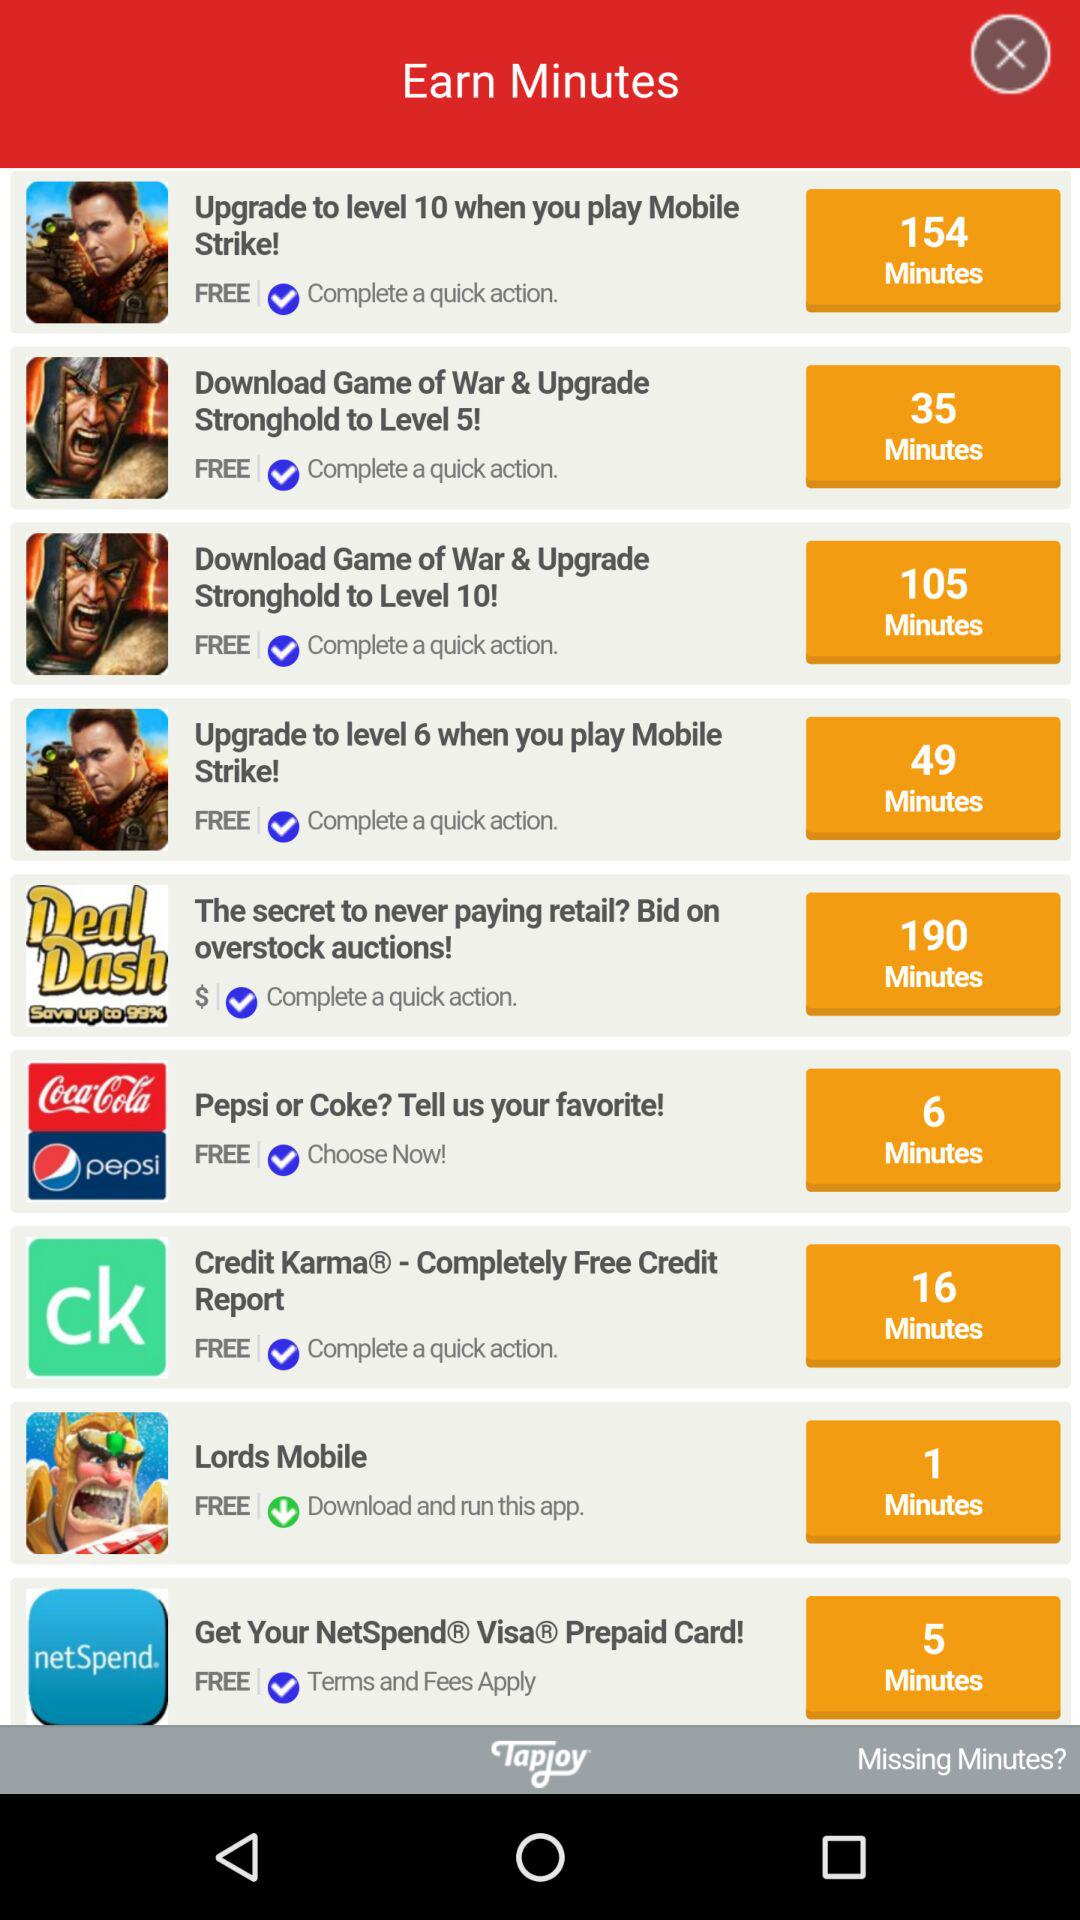How many minutes can be earned by downloading "Lords Mobile"? The number of minutes that can be earned by downloading "Lords Mobile" is 1. 